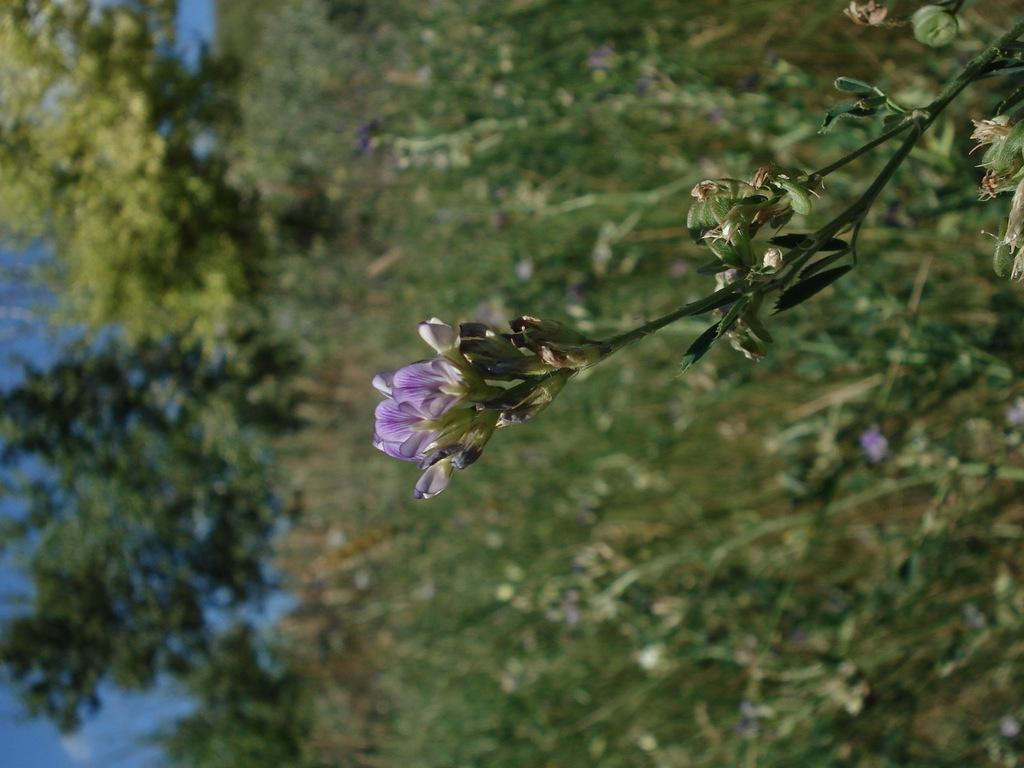What type of plant is visible in the image? There are flowers and buds on a plant in the image. What can be seen on the left side of the image? There are trees on the left side of the image. What is visible in the background of the image? The sky is visible in the image. Is there any milk visible in the image? No, there is no milk present in the image. 